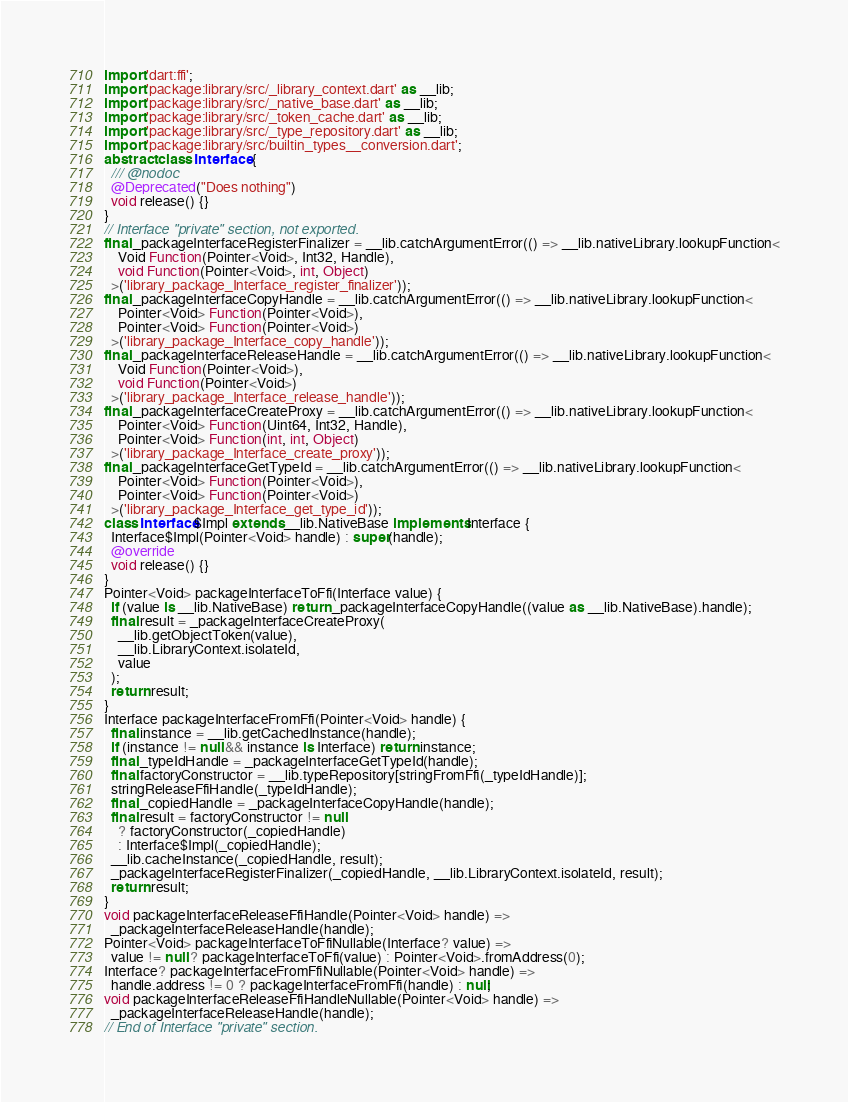<code> <loc_0><loc_0><loc_500><loc_500><_Dart_>import 'dart:ffi';
import 'package:library/src/_library_context.dart' as __lib;
import 'package:library/src/_native_base.dart' as __lib;
import 'package:library/src/_token_cache.dart' as __lib;
import 'package:library/src/_type_repository.dart' as __lib;
import 'package:library/src/builtin_types__conversion.dart';
abstract class Interface {
  /// @nodoc
  @Deprecated("Does nothing")
  void release() {}
}
// Interface "private" section, not exported.
final _packageInterfaceRegisterFinalizer = __lib.catchArgumentError(() => __lib.nativeLibrary.lookupFunction<
    Void Function(Pointer<Void>, Int32, Handle),
    void Function(Pointer<Void>, int, Object)
  >('library_package_Interface_register_finalizer'));
final _packageInterfaceCopyHandle = __lib.catchArgumentError(() => __lib.nativeLibrary.lookupFunction<
    Pointer<Void> Function(Pointer<Void>),
    Pointer<Void> Function(Pointer<Void>)
  >('library_package_Interface_copy_handle'));
final _packageInterfaceReleaseHandle = __lib.catchArgumentError(() => __lib.nativeLibrary.lookupFunction<
    Void Function(Pointer<Void>),
    void Function(Pointer<Void>)
  >('library_package_Interface_release_handle'));
final _packageInterfaceCreateProxy = __lib.catchArgumentError(() => __lib.nativeLibrary.lookupFunction<
    Pointer<Void> Function(Uint64, Int32, Handle),
    Pointer<Void> Function(int, int, Object)
  >('library_package_Interface_create_proxy'));
final _packageInterfaceGetTypeId = __lib.catchArgumentError(() => __lib.nativeLibrary.lookupFunction<
    Pointer<Void> Function(Pointer<Void>),
    Pointer<Void> Function(Pointer<Void>)
  >('library_package_Interface_get_type_id'));
class Interface$Impl extends __lib.NativeBase implements Interface {
  Interface$Impl(Pointer<Void> handle) : super(handle);
  @override
  void release() {}
}
Pointer<Void> packageInterfaceToFfi(Interface value) {
  if (value is __lib.NativeBase) return _packageInterfaceCopyHandle((value as __lib.NativeBase).handle);
  final result = _packageInterfaceCreateProxy(
    __lib.getObjectToken(value),
    __lib.LibraryContext.isolateId,
    value
  );
  return result;
}
Interface packageInterfaceFromFfi(Pointer<Void> handle) {
  final instance = __lib.getCachedInstance(handle);
  if (instance != null && instance is Interface) return instance;
  final _typeIdHandle = _packageInterfaceGetTypeId(handle);
  final factoryConstructor = __lib.typeRepository[stringFromFfi(_typeIdHandle)];
  stringReleaseFfiHandle(_typeIdHandle);
  final _copiedHandle = _packageInterfaceCopyHandle(handle);
  final result = factoryConstructor != null
    ? factoryConstructor(_copiedHandle)
    : Interface$Impl(_copiedHandle);
  __lib.cacheInstance(_copiedHandle, result);
  _packageInterfaceRegisterFinalizer(_copiedHandle, __lib.LibraryContext.isolateId, result);
  return result;
}
void packageInterfaceReleaseFfiHandle(Pointer<Void> handle) =>
  _packageInterfaceReleaseHandle(handle);
Pointer<Void> packageInterfaceToFfiNullable(Interface? value) =>
  value != null ? packageInterfaceToFfi(value) : Pointer<Void>.fromAddress(0);
Interface? packageInterfaceFromFfiNullable(Pointer<Void> handle) =>
  handle.address != 0 ? packageInterfaceFromFfi(handle) : null;
void packageInterfaceReleaseFfiHandleNullable(Pointer<Void> handle) =>
  _packageInterfaceReleaseHandle(handle);
// End of Interface "private" section.
</code> 